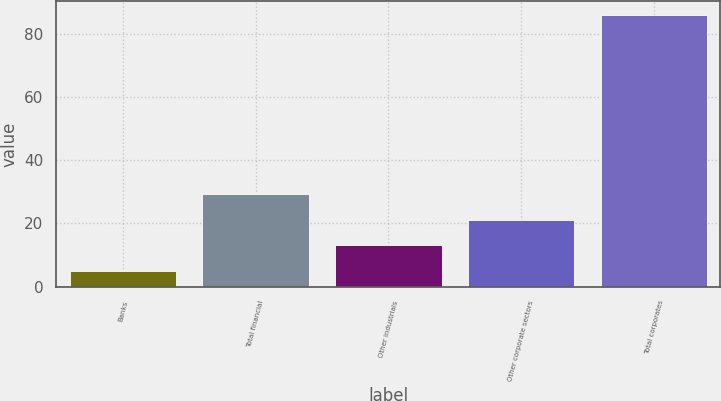<chart> <loc_0><loc_0><loc_500><loc_500><bar_chart><fcel>Banks<fcel>Total financial<fcel>Other industrials<fcel>Other corporate sectors<fcel>Total corporates<nl><fcel>5<fcel>29.3<fcel>13.1<fcel>21.2<fcel>86<nl></chart> 